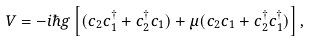Convert formula to latex. <formula><loc_0><loc_0><loc_500><loc_500>V = - i \hbar { g } \left [ ( c _ { 2 } c _ { 1 } ^ { \dagger } + c _ { 2 } ^ { \dagger } c _ { 1 } ) + \mu ( c _ { 2 } c _ { 1 } + c _ { 2 } ^ { \dagger } c _ { 1 } ^ { \dagger } ) \right ] ,</formula> 